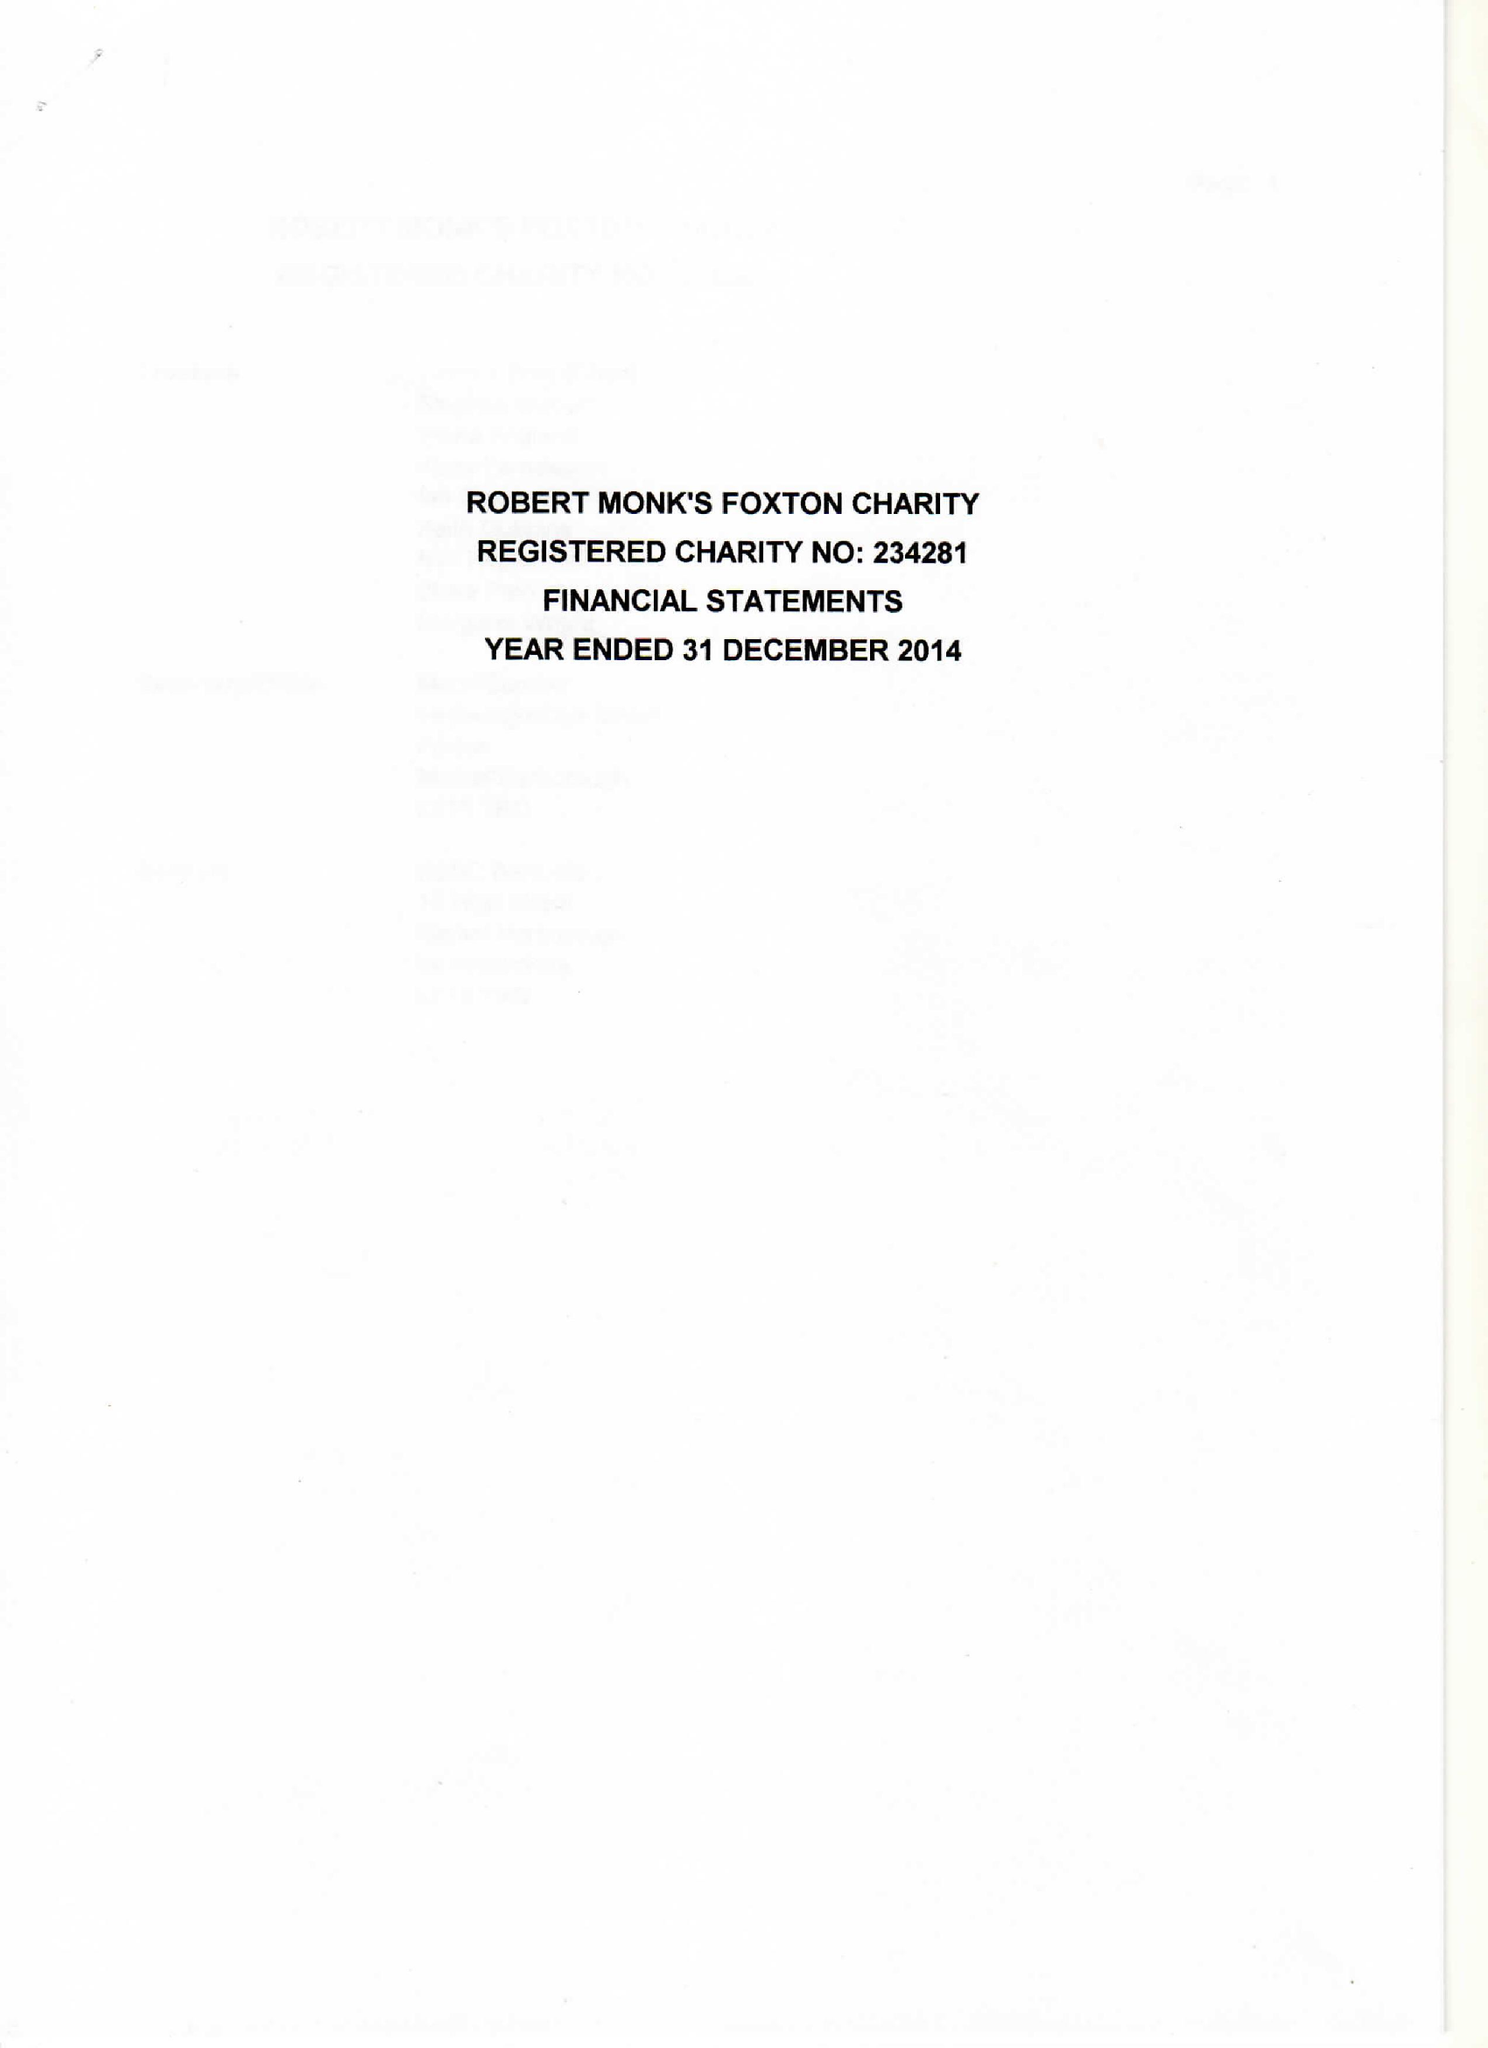What is the value for the charity_number?
Answer the question using a single word or phrase. 234281 